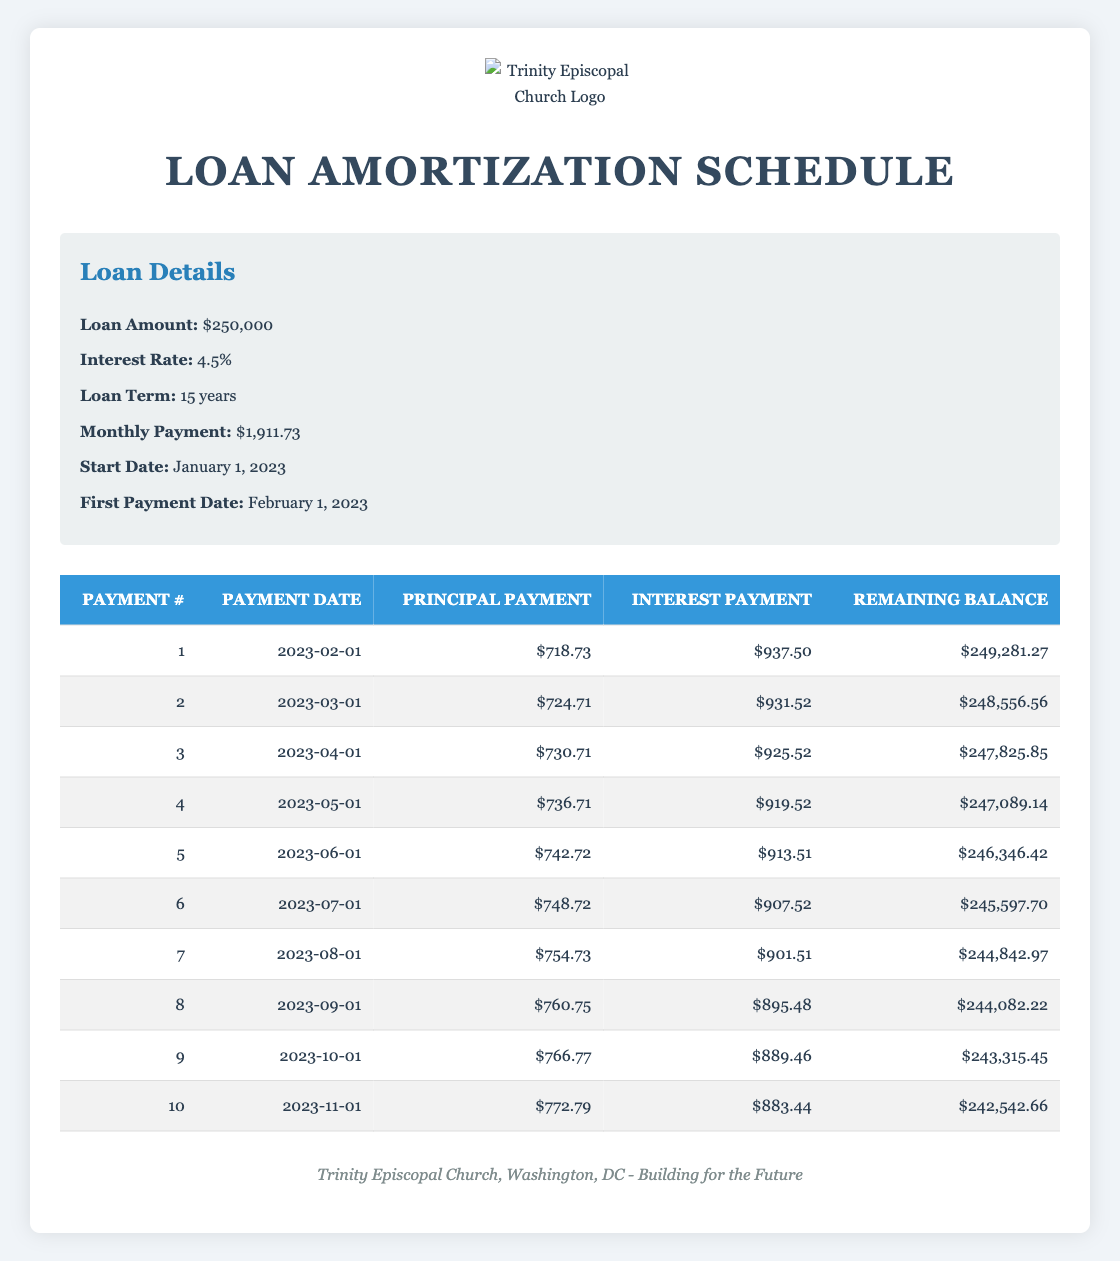What is the monthly principal payment for the first payment? In the table, the first row corresponding to payment number 1 shows a principal payment of $718.73.
Answer: 718.73 What is the remaining balance after the sixth payment? Looking at payment number 6 in the table, the remaining balance is listed as $245,597.70.
Answer: 245597.70 How much total interest is paid in the first three months? To find the total interest for the first three months, we sum the interest payments for payments 1, 2, and 3: $937.50 + $931.52 + $925.52 = $2,794.54.
Answer: 2794.54 Is the principal payment in the second month greater than the first month? The second month's principal payment is $724.71, while the first month's is $718.73. Since $724.71 is greater than $718.73, the answer is yes.
Answer: Yes What is the average principal payment over the first ten months? To find the average principal payment for the first ten months, sum all principal payments from payment numbers 1 to 10 and divide by 10. The sum is $718.73 + $724.71 + $730.71 + $736.71 + $742.72 + $748.72 + $754.73 + $760.75 + $766.77 + $772.79 = $7,548.53; thus, the average is $7,548.53 / 10 = $754.85.
Answer: 754.85 How much has the remaining balance decreased after ten payments? The remaining balance at the start of the loan is $250,000. After ten payments, it is $242,542.66. The decrease is $250,000 - $242,542.66 = $7,457.34.
Answer: 7457.34 Is the interest payment for the fourth month less than $920? The interest payment for the fourth month is $919.52, which is indeed less than $920, so the answer is yes.
Answer: Yes What is the total principal payment made after the first five payments? The total principal payment after the first five payments can be calculated by summing principal payments for payments 1 through 5: $718.73 + $724.71 + $730.71 + $736.71 + $742.72 = $3,733.58.
Answer: 3733.58 What is the difference in interest payment between the first and the fifth payment? From the table, the first payment's interest is $937.50 while the fifth payment's interest is $913.51. The difference is $937.50 - $913.51 = $23.99.
Answer: 23.99 What is the total amount paid in interest over the first ten months? For the first ten payments, we need to sum the interest payments: $937.50 + $931.52 + $925.52 + $919.52 + $913.51 + $907.52 + $901.51 + $895.48 + $889.46 + $883.44 = $9,252.52.
Answer: 9252.52 